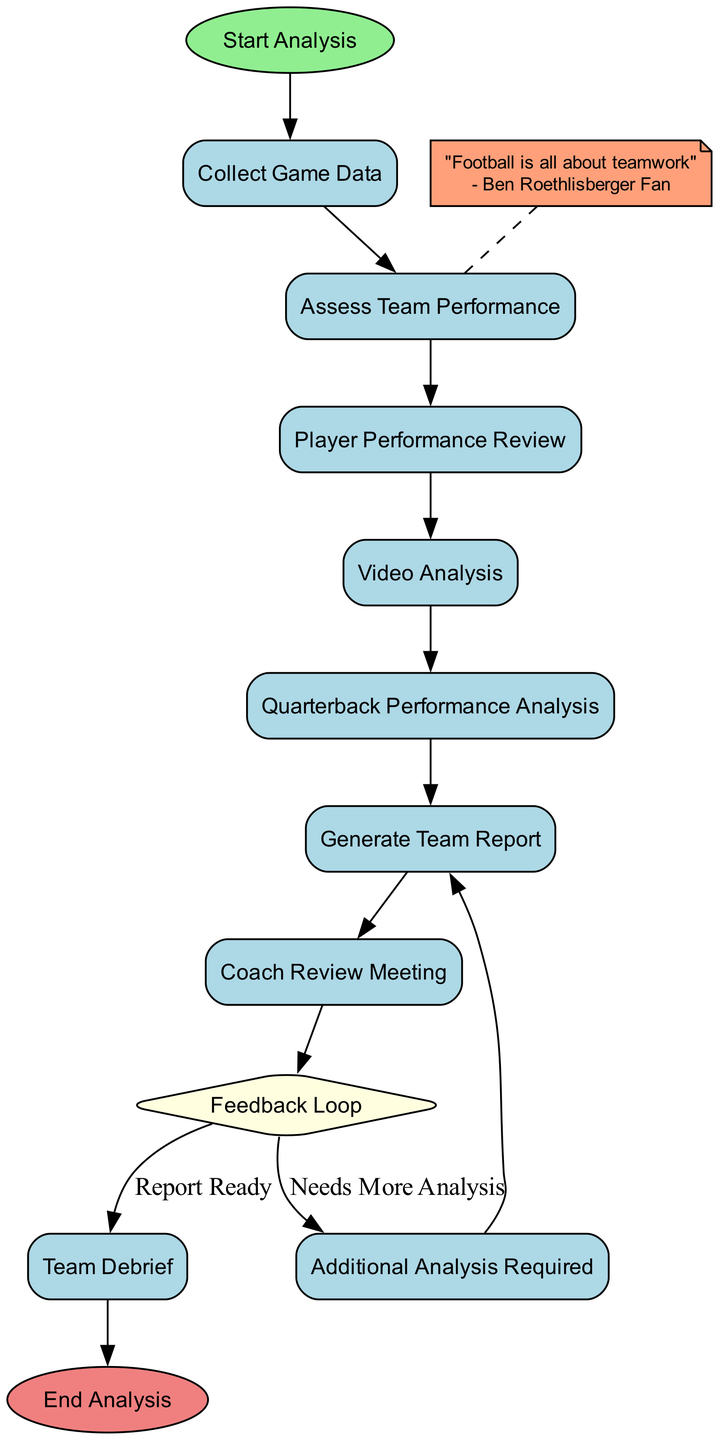What is the first action in the diagram? The diagram starts with the "Start Analysis" node, leading to the first action, which is "Collect Game Data." Thus, the first action that occurs after starting the analysis is to collect game data.
Answer: Collect Game Data How many actions are present in the diagram? To find the number of actions, we can count all the action nodes in the diagram after the start node. There are six actions: "Collect Game Data," "Assess Team Performance," "Player Performance Review," "Video Analysis," "Quarterback Performance Analysis," and "Generate Team Report."
Answer: Six What decision point is present in the diagram? There is one decision point in the diagram called "Feedback Loop." This is where a decision is made regarding whether additional analysis is needed or if the report is ready for the team.
Answer: Feedback Loop After the Coach Review Meeting, what can occur based on the Feedback Loop? After the "Coach Review Meeting," the flow leads to the "Feedback Loop." From there, based on the evaluation, it can either continue to "Team Debrief" if the report is ready or return to "Additional Analysis Required" if more analysis is needed.
Answer: Team Debrief or Additional Analysis Required What is the last action performed before the analysis ends? The last action before the diagram concludes with "End Analysis" is "Team Debrief." This is the final step where the entire team discusses the analysis results to reinforce teamwork and address improvements.
Answer: Team Debrief Which action is specifically focused on quarterback performance? The action that specifically concerns quarterback performance is "Quarterback Performance Analysis." This step emphasizes reviewing the quarterback's decision-making and execution during the game.
Answer: Quarterback Performance Analysis If additional analysis is needed, what is the next step after that? If the decision in the "Feedback Loop" indicates that additional analysis is required, the next step after that is to conduct "Additional Analysis Required." This leads back to generating the team report once the additional analysis has been completed.
Answer: Generate Team Report What is the role of the Coach Review Meeting in the diagram? The "Coach Review Meeting" is an action where the compiled findings from the analysis report are presented to the coaching staff for strategic discussions. This is vital for planning future strategies based on team performance.
Answer: Presenting the report to coaching staff How does the diagram emphasize teamwork according to the fan's quote? The diagram includes a note at the beginning that states, "Football is all about teamwork," attributed to a Ben Roethlisberger fan. This note is linked with the "Assess Team Performance" action, highlighting the importance of teamwork in evaluating overall team execution.
Answer: Teamwork emphasis through a note 